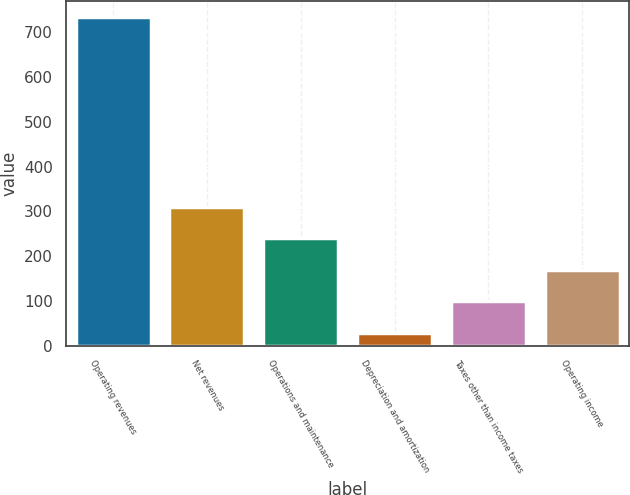Convert chart. <chart><loc_0><loc_0><loc_500><loc_500><bar_chart><fcel>Operating revenues<fcel>Net revenues<fcel>Operations and maintenance<fcel>Depreciation and amortization<fcel>Taxes other than income taxes<fcel>Operating income<nl><fcel>733<fcel>310.6<fcel>240.2<fcel>29<fcel>99.4<fcel>169.8<nl></chart> 